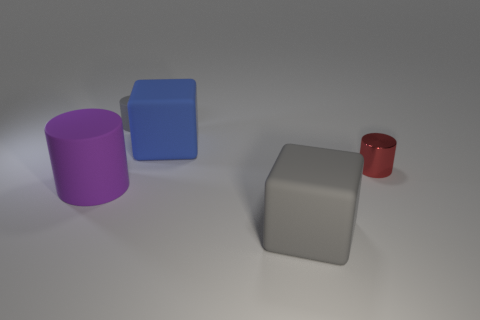Add 2 big gray objects. How many objects exist? 7 Subtract all blocks. How many objects are left? 3 Subtract 0 green cylinders. How many objects are left? 5 Subtract all tiny gray matte objects. Subtract all red rubber things. How many objects are left? 4 Add 4 tiny gray objects. How many tiny gray objects are left? 5 Add 5 big objects. How many big objects exist? 8 